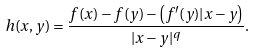Convert formula to latex. <formula><loc_0><loc_0><loc_500><loc_500>h ( x , y ) = \frac { f ( x ) - f ( y ) - \left ( f ^ { \prime } ( y ) | x - y \right ) } { | x - y | ^ { q } } .</formula> 